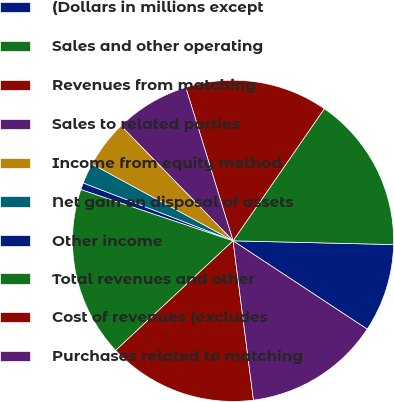Convert chart to OTSL. <chart><loc_0><loc_0><loc_500><loc_500><pie_chart><fcel>(Dollars in millions except<fcel>Sales and other operating<fcel>Revenues from matching<fcel>Sales to related parties<fcel>Income from equity method<fcel>Net gain on disposal of assets<fcel>Other income<fcel>Total revenues and other<fcel>Cost of revenues (excludes<fcel>Purchases related to matching<nl><fcel>8.9%<fcel>15.75%<fcel>14.38%<fcel>7.53%<fcel>4.79%<fcel>2.06%<fcel>0.69%<fcel>17.12%<fcel>15.07%<fcel>13.7%<nl></chart> 